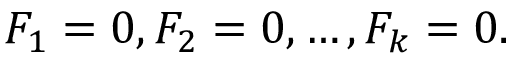Convert formula to latex. <formula><loc_0><loc_0><loc_500><loc_500>F _ { 1 } = 0 , F _ { 2 } = 0 , \dots , F _ { k } = 0 .</formula> 